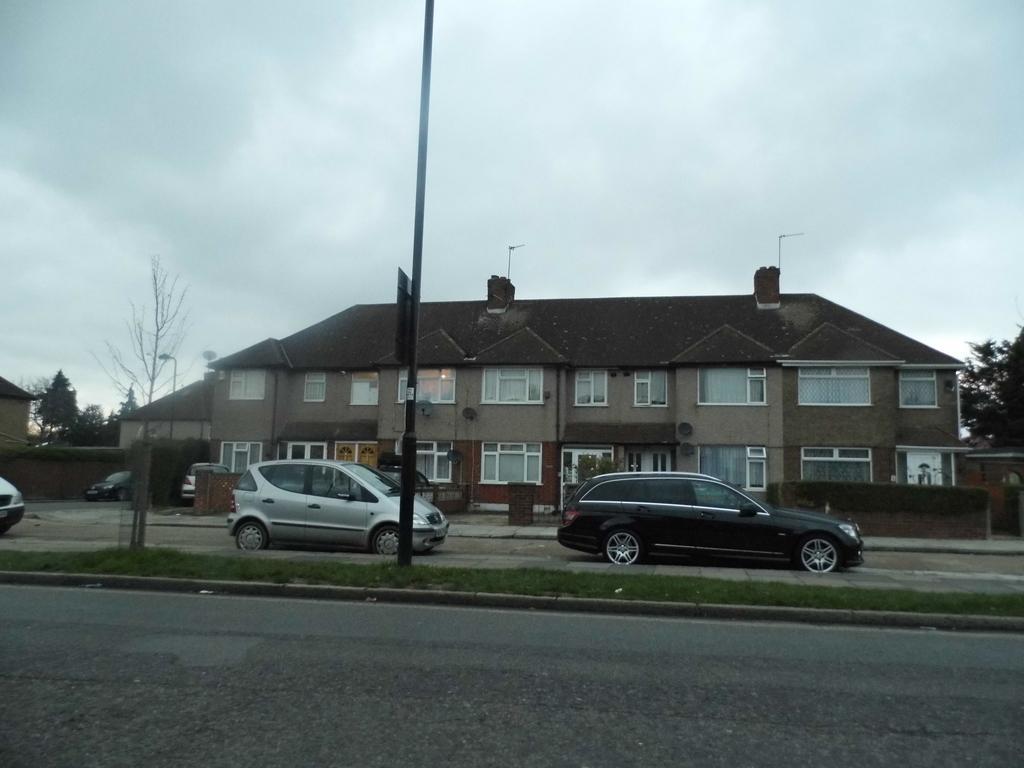Can you describe this image briefly? In the picture I can see cars are on the road, I can see board, pole, trees, houses, the wall and the cloudy sky is the background. 